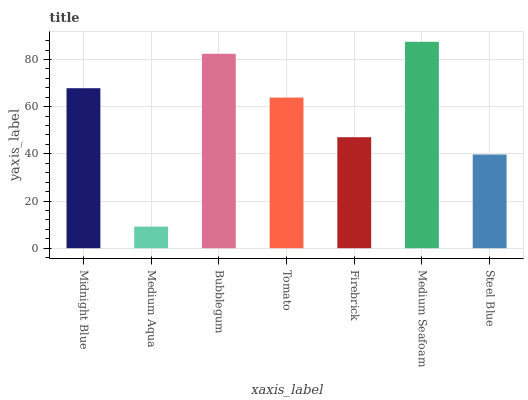Is Medium Aqua the minimum?
Answer yes or no. Yes. Is Medium Seafoam the maximum?
Answer yes or no. Yes. Is Bubblegum the minimum?
Answer yes or no. No. Is Bubblegum the maximum?
Answer yes or no. No. Is Bubblegum greater than Medium Aqua?
Answer yes or no. Yes. Is Medium Aqua less than Bubblegum?
Answer yes or no. Yes. Is Medium Aqua greater than Bubblegum?
Answer yes or no. No. Is Bubblegum less than Medium Aqua?
Answer yes or no. No. Is Tomato the high median?
Answer yes or no. Yes. Is Tomato the low median?
Answer yes or no. Yes. Is Steel Blue the high median?
Answer yes or no. No. Is Medium Seafoam the low median?
Answer yes or no. No. 